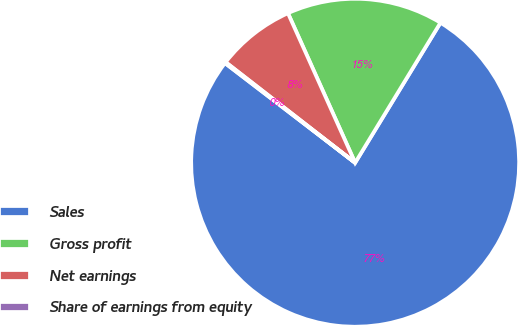<chart> <loc_0><loc_0><loc_500><loc_500><pie_chart><fcel>Sales<fcel>Gross profit<fcel>Net earnings<fcel>Share of earnings from equity<nl><fcel>76.69%<fcel>15.43%<fcel>7.77%<fcel>0.11%<nl></chart> 